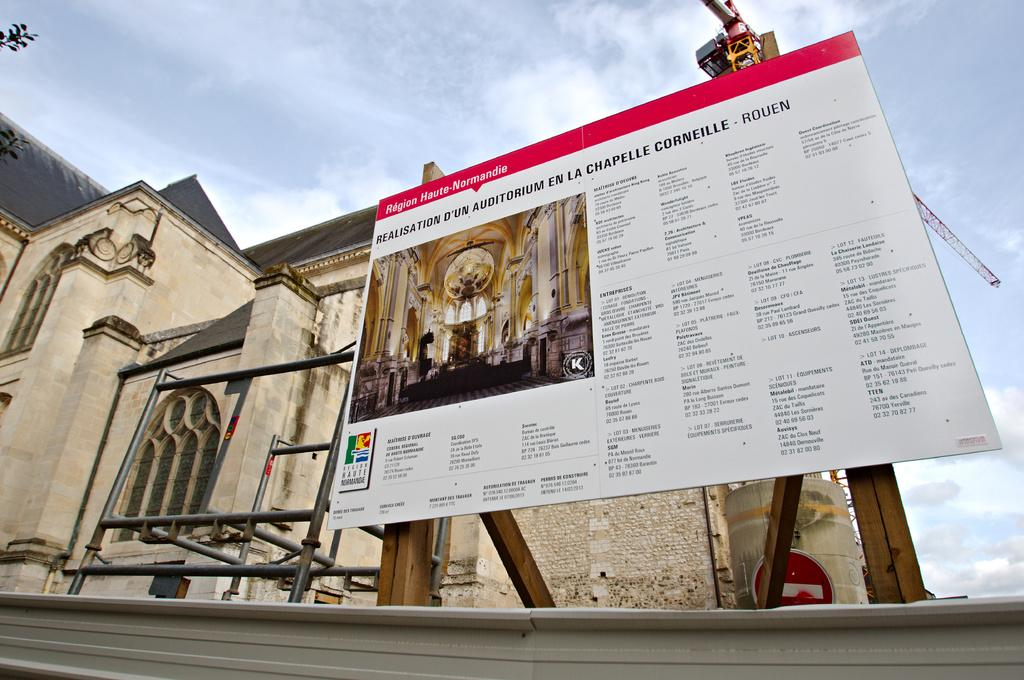Provide a one-sentence caption for the provided image. Region Haute-Normandie remodel sign sits near a church. 